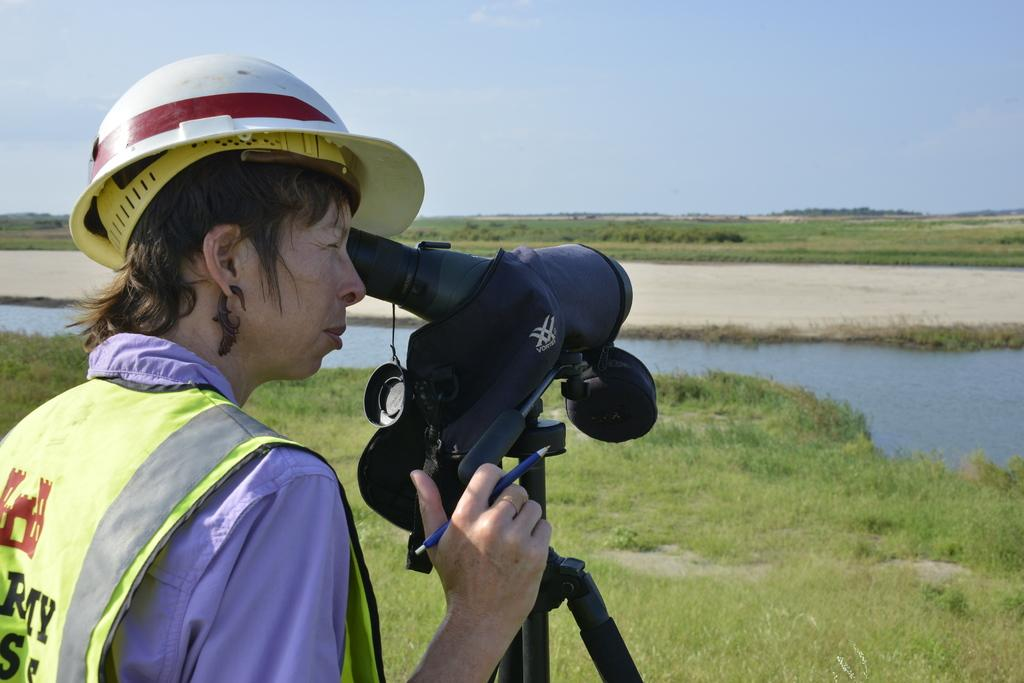What is the person in the image wearing on their head? The person in the image is wearing a hat. What equipment is set up for photography in the image? There is a camera with a tripod stand in the image. What type of terrain is visible in the image? There is grass and water visible in the image. What can be seen in the background of the image? The sky is visible in the background of the image. Where is the crib located in the image? There is no crib present in the image. What type of coach is visible in the image? There is no coach present in the image. 